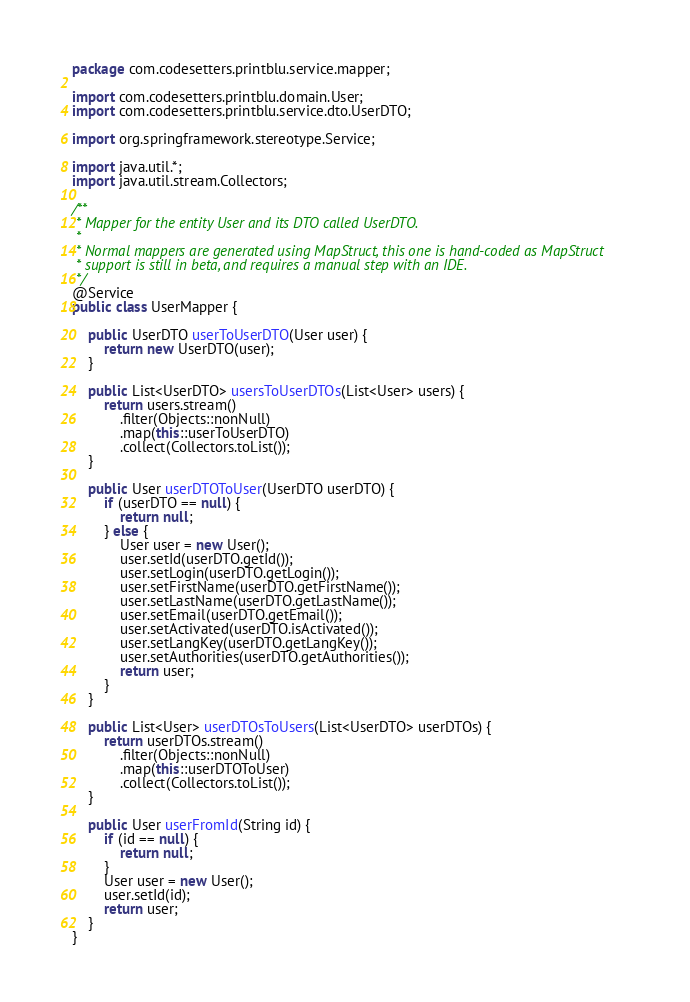Convert code to text. <code><loc_0><loc_0><loc_500><loc_500><_Java_>package com.codesetters.printblu.service.mapper;

import com.codesetters.printblu.domain.User;
import com.codesetters.printblu.service.dto.UserDTO;

import org.springframework.stereotype.Service;

import java.util.*;
import java.util.stream.Collectors;

/**
 * Mapper for the entity User and its DTO called UserDTO.
 *
 * Normal mappers are generated using MapStruct, this one is hand-coded as MapStruct
 * support is still in beta, and requires a manual step with an IDE.
 */
@Service
public class UserMapper {

    public UserDTO userToUserDTO(User user) {
        return new UserDTO(user);
    }

    public List<UserDTO> usersToUserDTOs(List<User> users) {
        return users.stream()
            .filter(Objects::nonNull)
            .map(this::userToUserDTO)
            .collect(Collectors.toList());
    }

    public User userDTOToUser(UserDTO userDTO) {
        if (userDTO == null) {
            return null;
        } else {
            User user = new User();
            user.setId(userDTO.getId());
            user.setLogin(userDTO.getLogin());
            user.setFirstName(userDTO.getFirstName());
            user.setLastName(userDTO.getLastName());
            user.setEmail(userDTO.getEmail());
            user.setActivated(userDTO.isActivated());
            user.setLangKey(userDTO.getLangKey());
            user.setAuthorities(userDTO.getAuthorities());
            return user;
        }
    }

    public List<User> userDTOsToUsers(List<UserDTO> userDTOs) {
        return userDTOs.stream()
            .filter(Objects::nonNull)
            .map(this::userDTOToUser)
            .collect(Collectors.toList());
    }

    public User userFromId(String id) {
        if (id == null) {
            return null;
        }
        User user = new User();
        user.setId(id);
        return user;
    }
}
</code> 